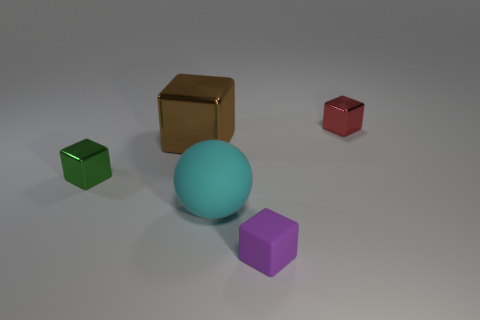What number of tiny purple matte cubes are in front of the big object that is on the left side of the matte ball?
Provide a short and direct response. 1. What is the material of the purple object that is the same size as the red metallic object?
Your answer should be very brief. Rubber. What number of other objects are there of the same material as the ball?
Offer a terse response. 1. What number of brown objects are in front of the large cyan matte sphere?
Your answer should be compact. 0. What number of cylinders are either big rubber things or small purple matte objects?
Ensure brevity in your answer.  0. How big is the cube that is behind the green shiny block and right of the brown metallic cube?
Offer a very short reply. Small. What number of other objects are the same color as the rubber cube?
Your answer should be compact. 0. Is the material of the tiny purple object the same as the large sphere that is behind the small purple matte block?
Your answer should be very brief. Yes. How many things are cubes that are left of the cyan rubber sphere or purple matte things?
Give a very brief answer. 3. There is a small object that is both right of the green metal cube and behind the cyan object; what is its shape?
Keep it short and to the point. Cube. 